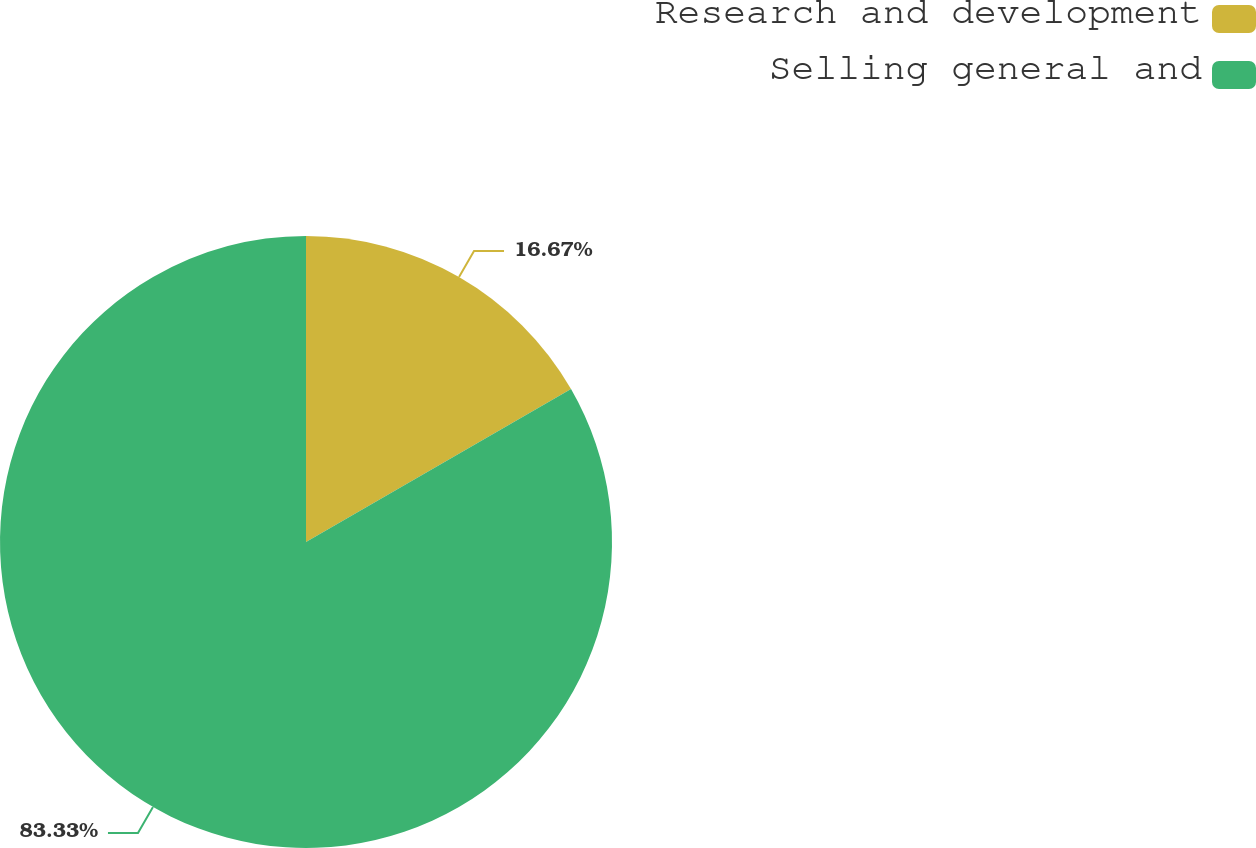<chart> <loc_0><loc_0><loc_500><loc_500><pie_chart><fcel>Research and development<fcel>Selling general and<nl><fcel>16.67%<fcel>83.33%<nl></chart> 